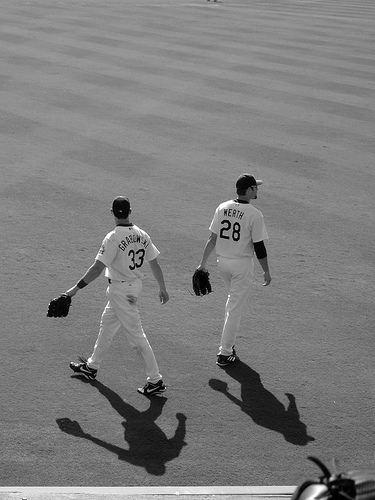Can you describe their uniforms in more detail? The players are wearing matching white uniforms with dark numerals and letters, which indicate their team numbers and potentially their names or team names. The jerseys are paired with long baseball pants and caps, completing the standard attire for baseball players. 